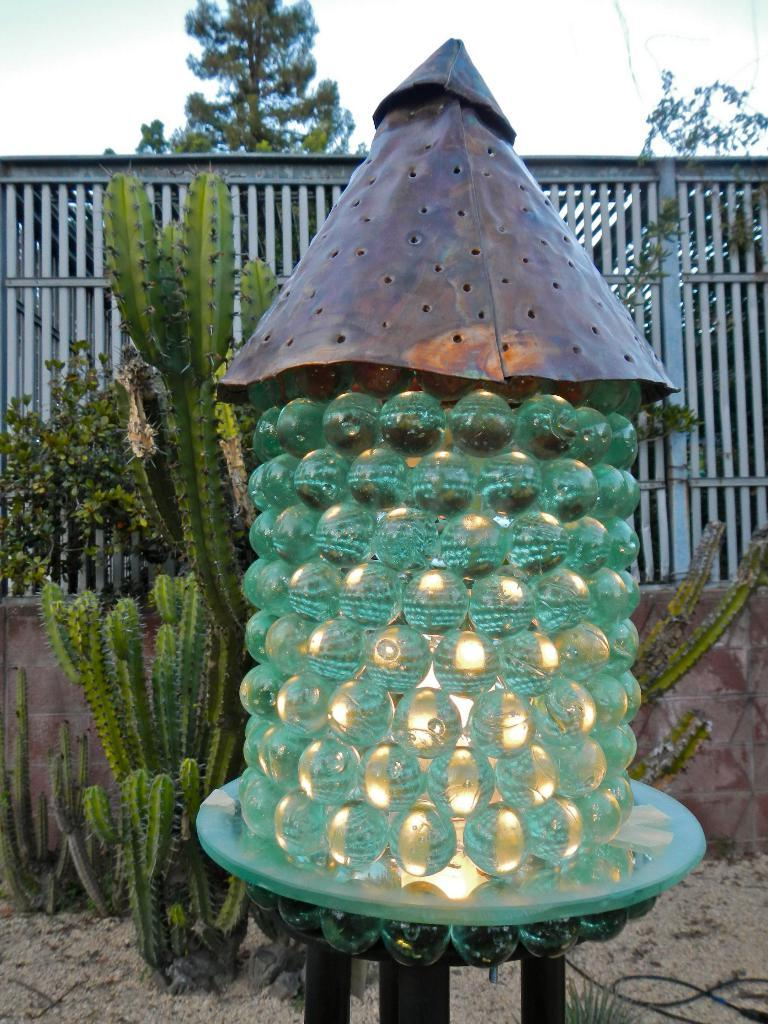What objects are on the stand in the image? There are green color marbles on a stand in the image. What feature of the stand is noteworthy? There is light inside the stand. What can be seen in the background of the image? Plants, trees, and a railing are visible in the background. What is the color of the sky in the image? The sky is blue and white in color. Can you see any veins in the marbles in the image? There are no veins visible in the marbles, as they are inanimate objects and do not have biological features like veins. 